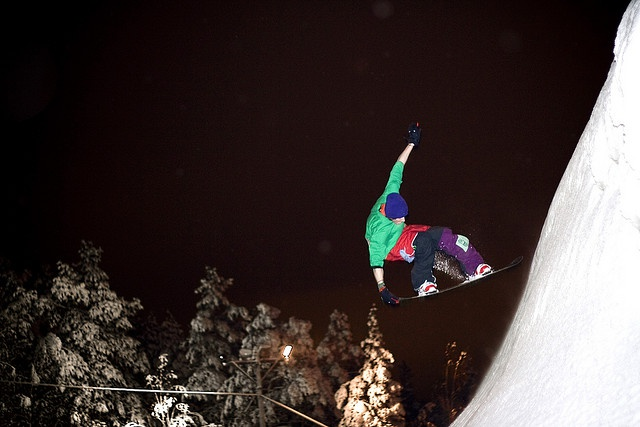Describe the objects in this image and their specific colors. I can see people in black, aquamarine, purple, and navy tones and snowboard in black, gray, and lightgray tones in this image. 